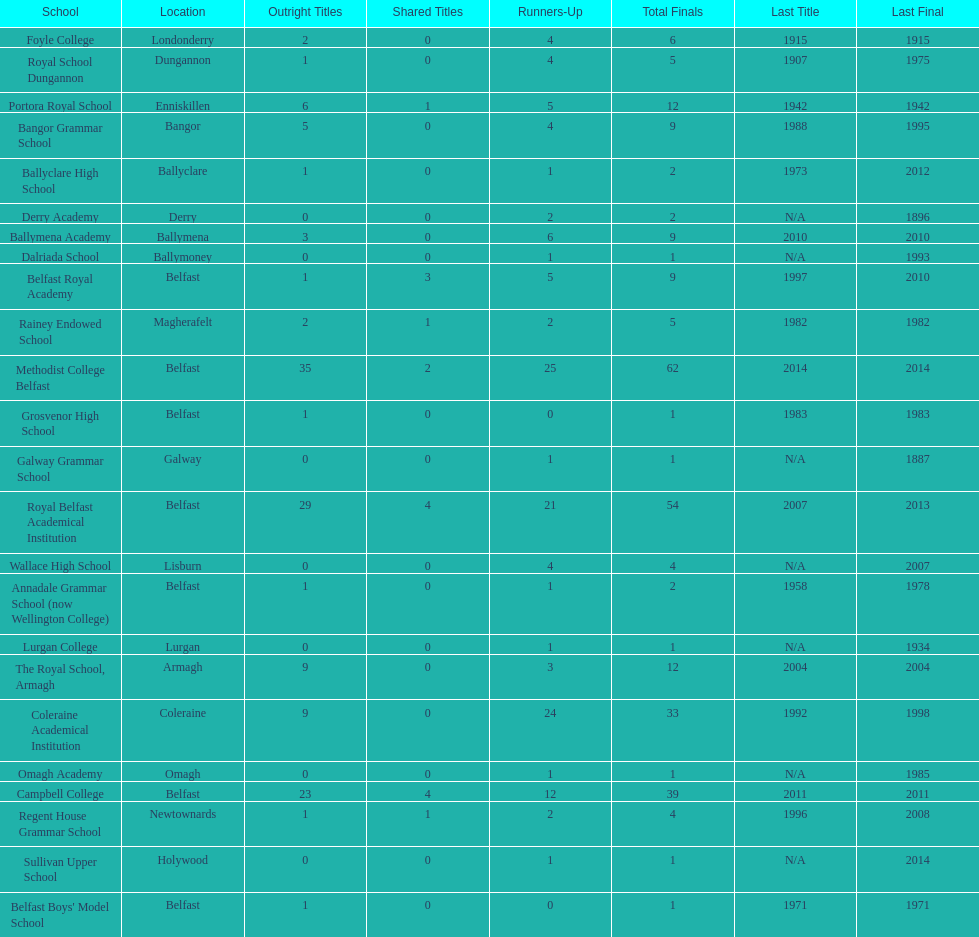What is the difference in runners-up from coleraine academical institution and royal school dungannon? 20. 